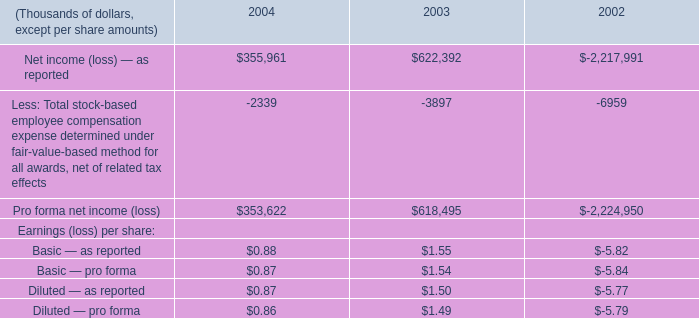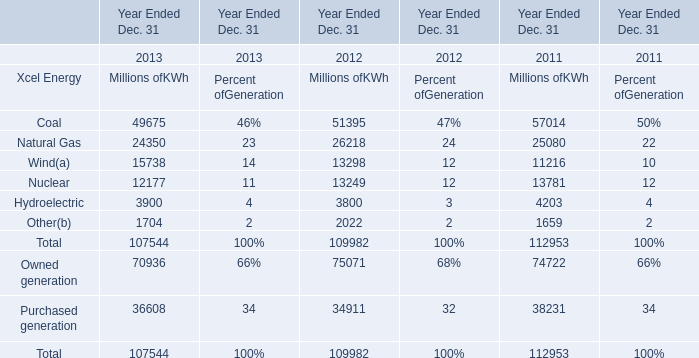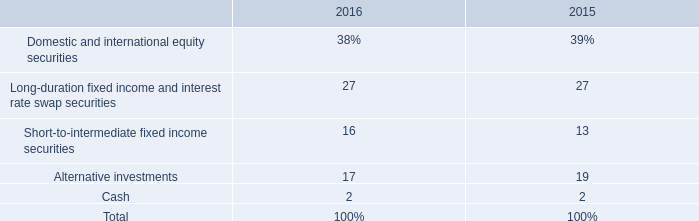What was the total amount of Xcel Energy in 2012 ? (in million) 
Computations: (((((51395 + 26218) + 13298) + 13249) + 3800) + 2022)
Answer: 109982.0. 